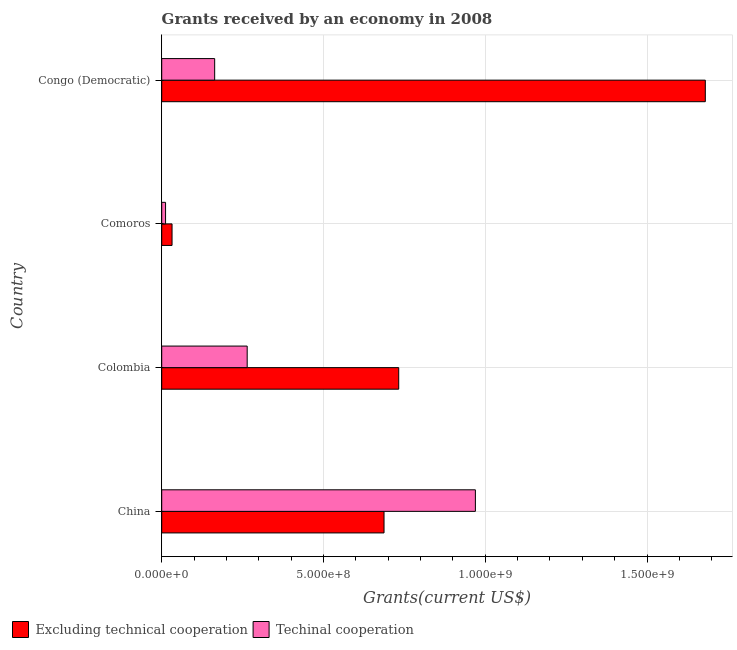What is the label of the 4th group of bars from the top?
Offer a very short reply. China. In how many cases, is the number of bars for a given country not equal to the number of legend labels?
Keep it short and to the point. 0. What is the amount of grants received(including technical cooperation) in Colombia?
Provide a short and direct response. 2.64e+08. Across all countries, what is the maximum amount of grants received(excluding technical cooperation)?
Ensure brevity in your answer.  1.68e+09. Across all countries, what is the minimum amount of grants received(including technical cooperation)?
Your answer should be compact. 1.19e+07. In which country was the amount of grants received(excluding technical cooperation) maximum?
Make the answer very short. Congo (Democratic). In which country was the amount of grants received(including technical cooperation) minimum?
Provide a short and direct response. Comoros. What is the total amount of grants received(including technical cooperation) in the graph?
Your answer should be very brief. 1.41e+09. What is the difference between the amount of grants received(excluding technical cooperation) in Colombia and that in Congo (Democratic)?
Provide a short and direct response. -9.48e+08. What is the difference between the amount of grants received(including technical cooperation) in Colombia and the amount of grants received(excluding technical cooperation) in Comoros?
Give a very brief answer. 2.32e+08. What is the average amount of grants received(excluding technical cooperation) per country?
Offer a very short reply. 7.83e+08. What is the difference between the amount of grants received(including technical cooperation) and amount of grants received(excluding technical cooperation) in Comoros?
Keep it short and to the point. -2.00e+07. In how many countries, is the amount of grants received(excluding technical cooperation) greater than 100000000 US$?
Your response must be concise. 3. What is the ratio of the amount of grants received(including technical cooperation) in China to that in Congo (Democratic)?
Ensure brevity in your answer.  5.92. What is the difference between the highest and the second highest amount of grants received(excluding technical cooperation)?
Provide a succinct answer. 9.48e+08. What is the difference between the highest and the lowest amount of grants received(including technical cooperation)?
Offer a terse response. 9.58e+08. In how many countries, is the amount of grants received(excluding technical cooperation) greater than the average amount of grants received(excluding technical cooperation) taken over all countries?
Give a very brief answer. 1. Is the sum of the amount of grants received(including technical cooperation) in Comoros and Congo (Democratic) greater than the maximum amount of grants received(excluding technical cooperation) across all countries?
Ensure brevity in your answer.  No. What does the 2nd bar from the top in China represents?
Give a very brief answer. Excluding technical cooperation. What does the 1st bar from the bottom in Colombia represents?
Ensure brevity in your answer.  Excluding technical cooperation. What is the difference between two consecutive major ticks on the X-axis?
Make the answer very short. 5.00e+08. Does the graph contain any zero values?
Provide a succinct answer. No. Where does the legend appear in the graph?
Ensure brevity in your answer.  Bottom left. What is the title of the graph?
Offer a terse response. Grants received by an economy in 2008. Does "Underweight" appear as one of the legend labels in the graph?
Keep it short and to the point. No. What is the label or title of the X-axis?
Ensure brevity in your answer.  Grants(current US$). What is the label or title of the Y-axis?
Ensure brevity in your answer.  Country. What is the Grants(current US$) in Excluding technical cooperation in China?
Make the answer very short. 6.87e+08. What is the Grants(current US$) of Techinal cooperation in China?
Keep it short and to the point. 9.70e+08. What is the Grants(current US$) of Excluding technical cooperation in Colombia?
Your answer should be very brief. 7.33e+08. What is the Grants(current US$) in Techinal cooperation in Colombia?
Offer a very short reply. 2.64e+08. What is the Grants(current US$) in Excluding technical cooperation in Comoros?
Offer a very short reply. 3.20e+07. What is the Grants(current US$) of Techinal cooperation in Comoros?
Ensure brevity in your answer.  1.19e+07. What is the Grants(current US$) of Excluding technical cooperation in Congo (Democratic)?
Your answer should be compact. 1.68e+09. What is the Grants(current US$) in Techinal cooperation in Congo (Democratic)?
Your answer should be very brief. 1.64e+08. Across all countries, what is the maximum Grants(current US$) in Excluding technical cooperation?
Offer a very short reply. 1.68e+09. Across all countries, what is the maximum Grants(current US$) in Techinal cooperation?
Give a very brief answer. 9.70e+08. Across all countries, what is the minimum Grants(current US$) of Excluding technical cooperation?
Your answer should be very brief. 3.20e+07. Across all countries, what is the minimum Grants(current US$) of Techinal cooperation?
Offer a terse response. 1.19e+07. What is the total Grants(current US$) in Excluding technical cooperation in the graph?
Offer a very short reply. 3.13e+09. What is the total Grants(current US$) of Techinal cooperation in the graph?
Your answer should be very brief. 1.41e+09. What is the difference between the Grants(current US$) of Excluding technical cooperation in China and that in Colombia?
Give a very brief answer. -4.54e+07. What is the difference between the Grants(current US$) of Techinal cooperation in China and that in Colombia?
Your answer should be compact. 7.05e+08. What is the difference between the Grants(current US$) of Excluding technical cooperation in China and that in Comoros?
Offer a very short reply. 6.55e+08. What is the difference between the Grants(current US$) in Techinal cooperation in China and that in Comoros?
Make the answer very short. 9.58e+08. What is the difference between the Grants(current US$) in Excluding technical cooperation in China and that in Congo (Democratic)?
Provide a succinct answer. -9.93e+08. What is the difference between the Grants(current US$) of Techinal cooperation in China and that in Congo (Democratic)?
Ensure brevity in your answer.  8.06e+08. What is the difference between the Grants(current US$) of Excluding technical cooperation in Colombia and that in Comoros?
Your answer should be compact. 7.01e+08. What is the difference between the Grants(current US$) in Techinal cooperation in Colombia and that in Comoros?
Offer a terse response. 2.52e+08. What is the difference between the Grants(current US$) in Excluding technical cooperation in Colombia and that in Congo (Democratic)?
Offer a very short reply. -9.48e+08. What is the difference between the Grants(current US$) in Techinal cooperation in Colombia and that in Congo (Democratic)?
Your answer should be very brief. 1.01e+08. What is the difference between the Grants(current US$) of Excluding technical cooperation in Comoros and that in Congo (Democratic)?
Ensure brevity in your answer.  -1.65e+09. What is the difference between the Grants(current US$) of Techinal cooperation in Comoros and that in Congo (Democratic)?
Offer a terse response. -1.52e+08. What is the difference between the Grants(current US$) in Excluding technical cooperation in China and the Grants(current US$) in Techinal cooperation in Colombia?
Give a very brief answer. 4.23e+08. What is the difference between the Grants(current US$) in Excluding technical cooperation in China and the Grants(current US$) in Techinal cooperation in Comoros?
Ensure brevity in your answer.  6.75e+08. What is the difference between the Grants(current US$) in Excluding technical cooperation in China and the Grants(current US$) in Techinal cooperation in Congo (Democratic)?
Keep it short and to the point. 5.23e+08. What is the difference between the Grants(current US$) in Excluding technical cooperation in Colombia and the Grants(current US$) in Techinal cooperation in Comoros?
Provide a short and direct response. 7.21e+08. What is the difference between the Grants(current US$) of Excluding technical cooperation in Colombia and the Grants(current US$) of Techinal cooperation in Congo (Democratic)?
Give a very brief answer. 5.69e+08. What is the difference between the Grants(current US$) in Excluding technical cooperation in Comoros and the Grants(current US$) in Techinal cooperation in Congo (Democratic)?
Give a very brief answer. -1.32e+08. What is the average Grants(current US$) in Excluding technical cooperation per country?
Ensure brevity in your answer.  7.83e+08. What is the average Grants(current US$) in Techinal cooperation per country?
Your response must be concise. 3.52e+08. What is the difference between the Grants(current US$) of Excluding technical cooperation and Grants(current US$) of Techinal cooperation in China?
Provide a succinct answer. -2.82e+08. What is the difference between the Grants(current US$) in Excluding technical cooperation and Grants(current US$) in Techinal cooperation in Colombia?
Give a very brief answer. 4.68e+08. What is the difference between the Grants(current US$) of Excluding technical cooperation and Grants(current US$) of Techinal cooperation in Comoros?
Your answer should be compact. 2.00e+07. What is the difference between the Grants(current US$) in Excluding technical cooperation and Grants(current US$) in Techinal cooperation in Congo (Democratic)?
Your answer should be compact. 1.52e+09. What is the ratio of the Grants(current US$) in Excluding technical cooperation in China to that in Colombia?
Offer a terse response. 0.94. What is the ratio of the Grants(current US$) in Techinal cooperation in China to that in Colombia?
Your answer should be very brief. 3.67. What is the ratio of the Grants(current US$) of Excluding technical cooperation in China to that in Comoros?
Make the answer very short. 21.51. What is the ratio of the Grants(current US$) of Techinal cooperation in China to that in Comoros?
Offer a very short reply. 81.34. What is the ratio of the Grants(current US$) in Excluding technical cooperation in China to that in Congo (Democratic)?
Keep it short and to the point. 0.41. What is the ratio of the Grants(current US$) of Techinal cooperation in China to that in Congo (Democratic)?
Your answer should be very brief. 5.92. What is the ratio of the Grants(current US$) of Excluding technical cooperation in Colombia to that in Comoros?
Your response must be concise. 22.93. What is the ratio of the Grants(current US$) in Techinal cooperation in Colombia to that in Comoros?
Make the answer very short. 22.17. What is the ratio of the Grants(current US$) in Excluding technical cooperation in Colombia to that in Congo (Democratic)?
Your answer should be compact. 0.44. What is the ratio of the Grants(current US$) of Techinal cooperation in Colombia to that in Congo (Democratic)?
Keep it short and to the point. 1.61. What is the ratio of the Grants(current US$) of Excluding technical cooperation in Comoros to that in Congo (Democratic)?
Your response must be concise. 0.02. What is the ratio of the Grants(current US$) of Techinal cooperation in Comoros to that in Congo (Democratic)?
Offer a terse response. 0.07. What is the difference between the highest and the second highest Grants(current US$) in Excluding technical cooperation?
Your response must be concise. 9.48e+08. What is the difference between the highest and the second highest Grants(current US$) of Techinal cooperation?
Ensure brevity in your answer.  7.05e+08. What is the difference between the highest and the lowest Grants(current US$) in Excluding technical cooperation?
Your answer should be compact. 1.65e+09. What is the difference between the highest and the lowest Grants(current US$) of Techinal cooperation?
Make the answer very short. 9.58e+08. 